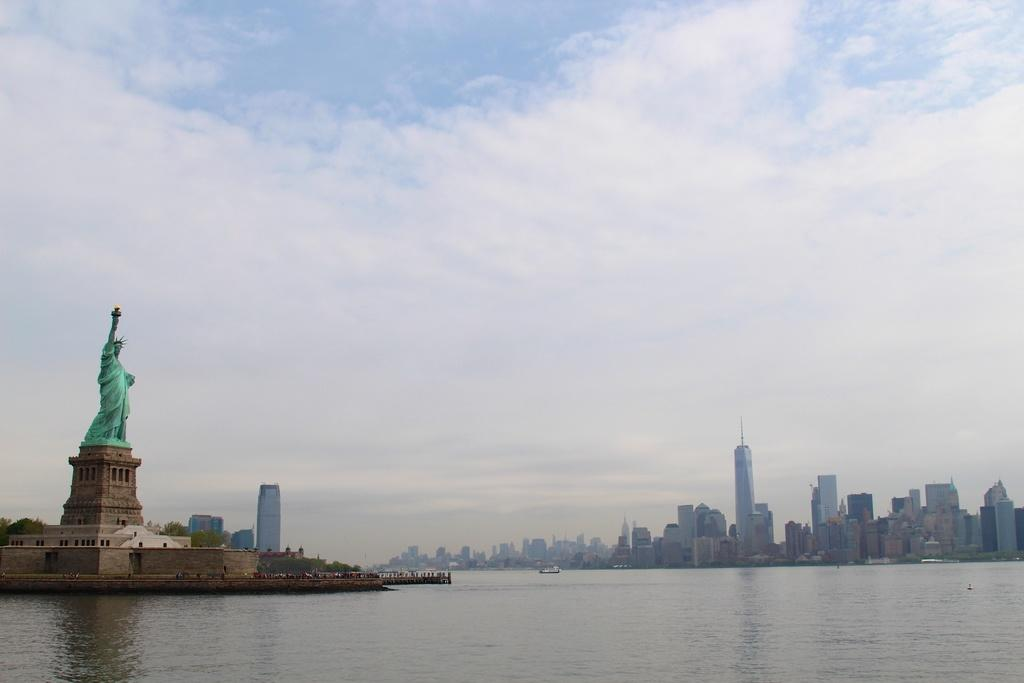What is located in the foreground of the image? There is a water body in the foreground of the image. What can be seen on the left side of the image? There are trees and a building on the left side of the image, as well as the Statue of Liberty. What is present on the right side of the image? There are buildings and a boat on the right side of the image. What is visible at the top of the image? The sky is visible at the top of the image. What type of reward is being given to the rod in the image? There is no reward or rod present in the image. How many rings are visible on the boat in the image? There are no rings visible on the boat in the image. 